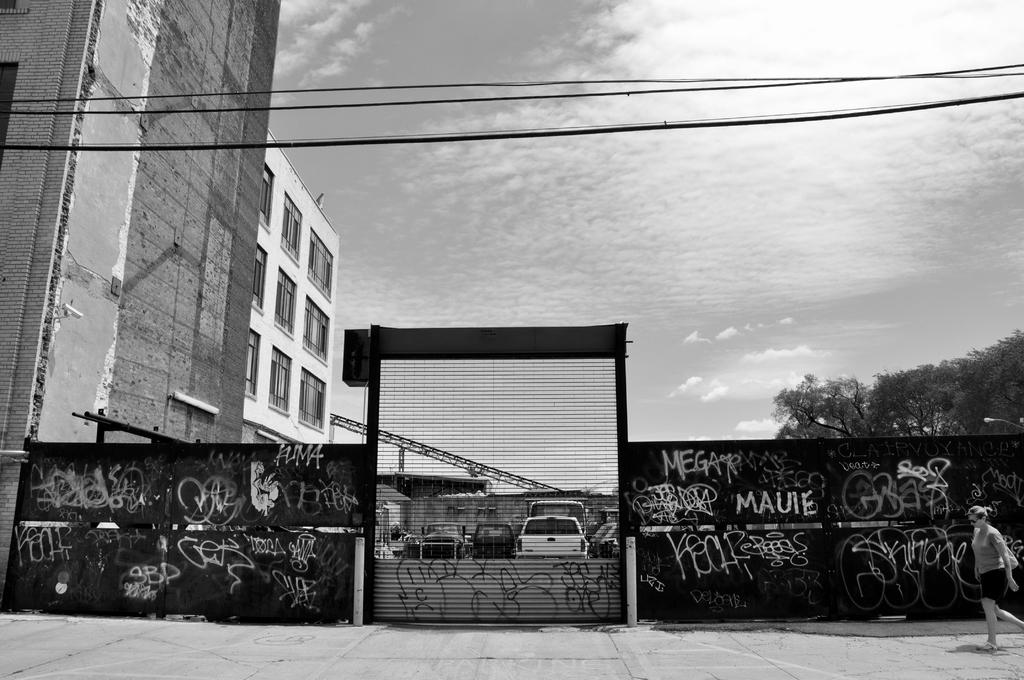Who is the main subject in the foreground of the image? There is a woman in the foreground of the image. What is the woman's location in the image? The woman is on the road. What can be seen in the foreground of the image besides the woman? There is a wall fence and fleets of cars in the foreground of the image. What is visible in the background of the image? There are buildings, wires, and the sky visible in the background of the image. How many pizzas are being delivered through the hole in the wall fence in the image? There is no hole in the wall fence, nor are there any pizzas present in the image. 